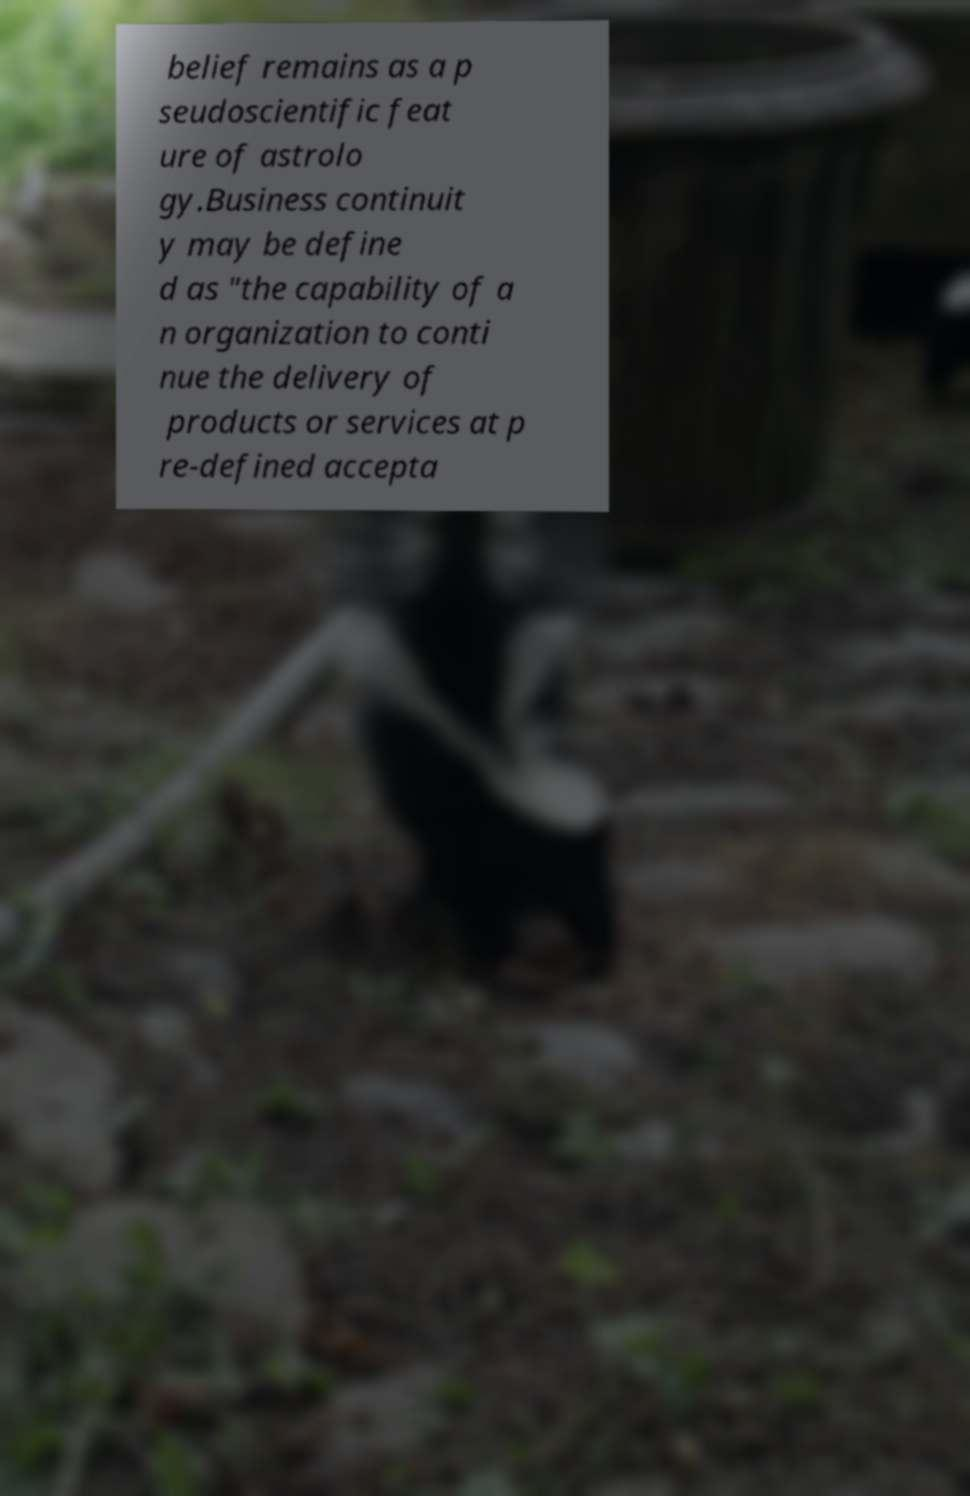There's text embedded in this image that I need extracted. Can you transcribe it verbatim? belief remains as a p seudoscientific feat ure of astrolo gy.Business continuit y may be define d as "the capability of a n organization to conti nue the delivery of products or services at p re-defined accepta 